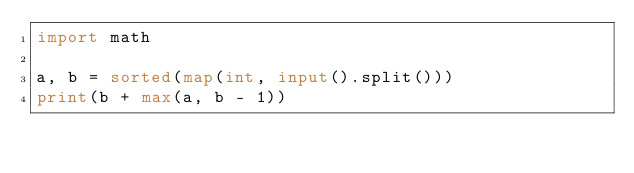<code> <loc_0><loc_0><loc_500><loc_500><_Python_>import math

a, b = sorted(map(int, input().split()))
print(b + max(a, b - 1))
</code> 